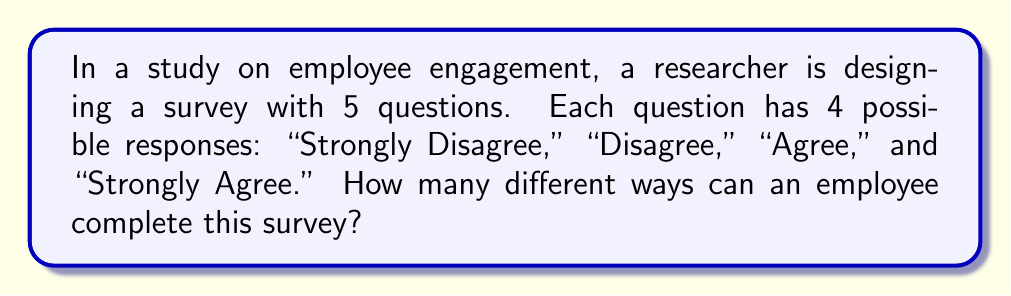Teach me how to tackle this problem. To solve this problem, we need to use the multiplication principle of counting. Here's the step-by-step approach:

1. Analyze the structure of the survey:
   - There are 5 questions in total.
   - Each question has 4 possible responses.

2. For each question, an employee has 4 choices:
   - This means there are 4 possibilities for each question.

3. The employee must answer all 5 questions:
   - We need to consider the number of possibilities for each question independently.

4. Apply the multiplication principle:
   - When we have independent events, we multiply the number of possibilities for each event.
   - In this case, we have 5 independent questions, each with 4 possibilities.

5. Calculate the total number of combinations:
   $$\text{Total combinations} = 4 \times 4 \times 4 \times 4 \times 4 = 4^5$$

6. Compute the final result:
   $$4^5 = 1,024$$

Therefore, there are 1,024 different ways an employee can complete this survey.
Answer: $4^5 = 1,024$ combinations 